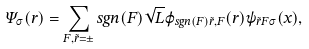<formula> <loc_0><loc_0><loc_500><loc_500>\Psi _ { \sigma } ( \vec { r } ) = \sum _ { F , \tilde { r } = \pm } s g n ( F ) \sqrt { L } { \varphi } _ { s g n ( F ) \tilde { r } , F } ( \vec { r } ) \psi _ { \tilde { r } F \sigma } ( x ) ,</formula> 